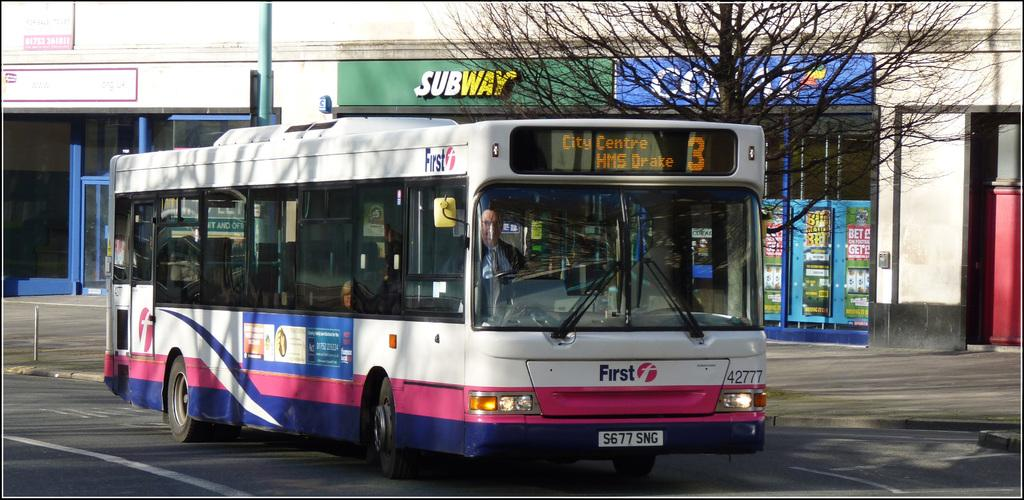Provide a one-sentence caption for the provided image. a colorful bus number 3 for Centre HMS Drake. 